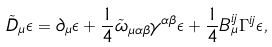<formula> <loc_0><loc_0><loc_500><loc_500>\tilde { D } _ { \mu } \epsilon = \partial _ { \mu } \epsilon + \frac { 1 } { 4 } \tilde { \omega } _ { \mu \alpha \beta } \gamma ^ { \alpha \beta } \epsilon + \frac { 1 } { 4 } B _ { \mu } ^ { i j } \Gamma ^ { i j } \epsilon ,</formula> 